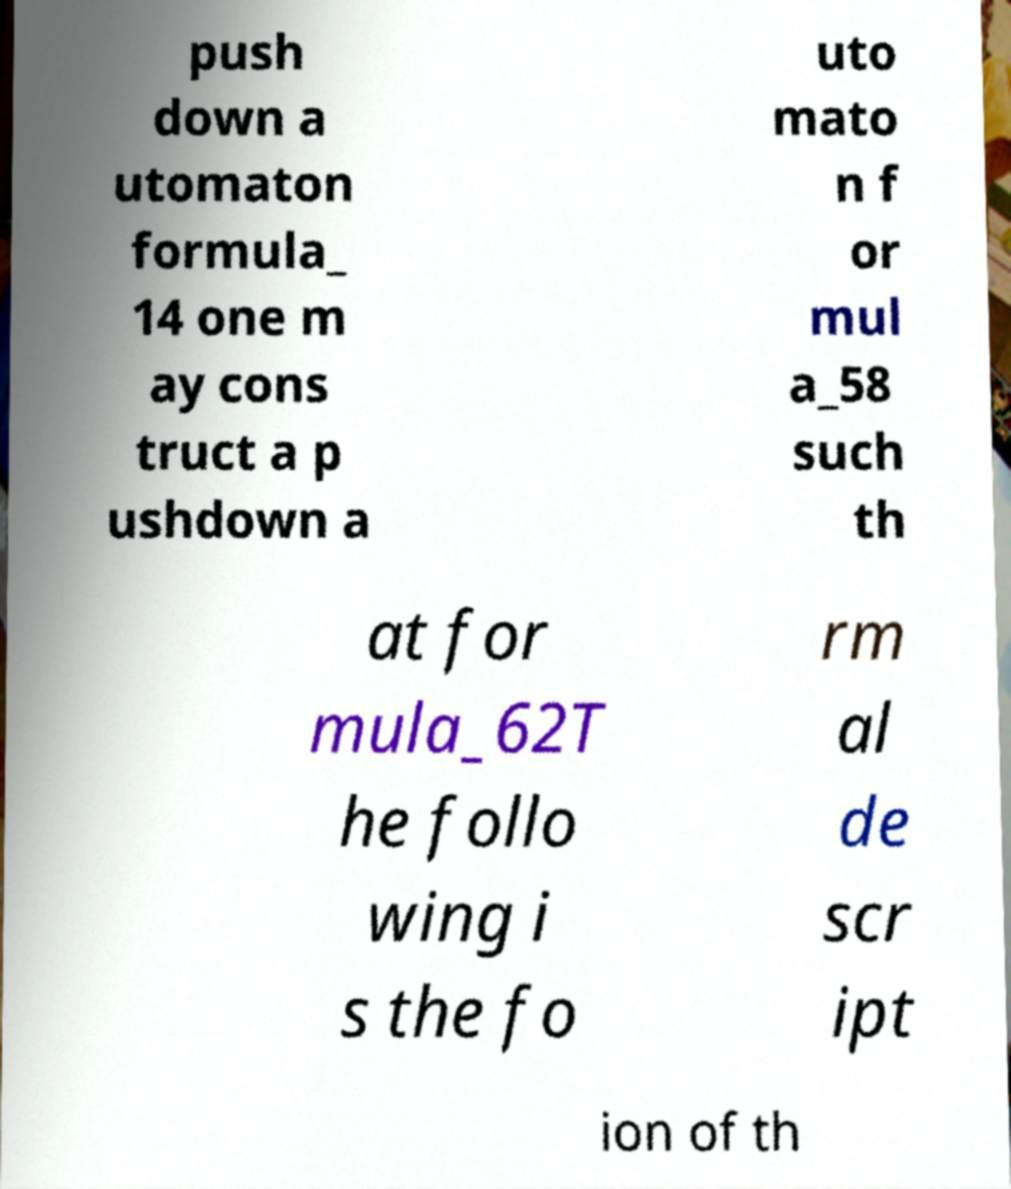What messages or text are displayed in this image? I need them in a readable, typed format. push down a utomaton formula_ 14 one m ay cons truct a p ushdown a uto mato n f or mul a_58 such th at for mula_62T he follo wing i s the fo rm al de scr ipt ion of th 